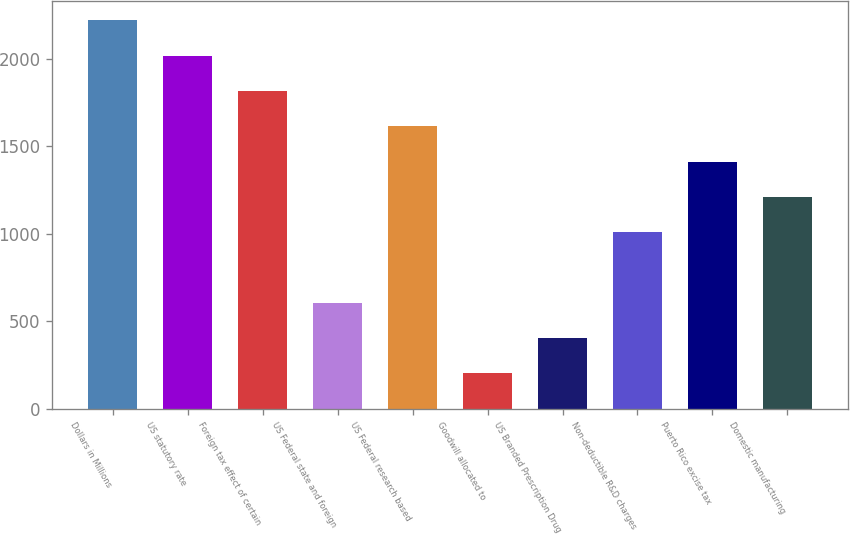Convert chart to OTSL. <chart><loc_0><loc_0><loc_500><loc_500><bar_chart><fcel>Dollars in Millions<fcel>US statutory rate<fcel>Foreign tax effect of certain<fcel>US Federal state and foreign<fcel>US Federal research based<fcel>Goodwill allocated to<fcel>US Branded Prescription Drug<fcel>Non-deductible R&D charges<fcel>Puerto Rico excise tax<fcel>Domestic manufacturing<nl><fcel>2217.56<fcel>2016<fcel>1814.44<fcel>605.08<fcel>1612.88<fcel>201.96<fcel>403.52<fcel>1008.2<fcel>1411.32<fcel>1209.76<nl></chart> 